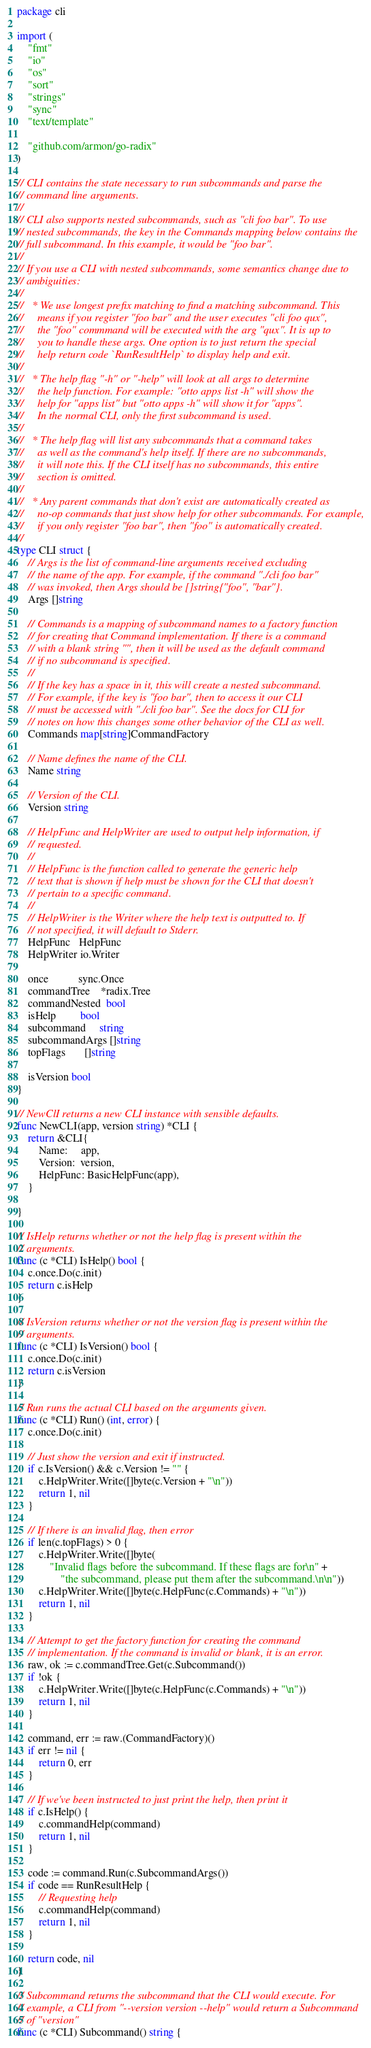<code> <loc_0><loc_0><loc_500><loc_500><_Go_>package cli

import (
	"fmt"
	"io"
	"os"
	"sort"
	"strings"
	"sync"
	"text/template"

	"github.com/armon/go-radix"
)

// CLI contains the state necessary to run subcommands and parse the
// command line arguments.
//
// CLI also supports nested subcommands, such as "cli foo bar". To use
// nested subcommands, the key in the Commands mapping below contains the
// full subcommand. In this example, it would be "foo bar".
//
// If you use a CLI with nested subcommands, some semantics change due to
// ambiguities:
//
//   * We use longest prefix matching to find a matching subcommand. This
//     means if you register "foo bar" and the user executes "cli foo qux",
//     the "foo" commmand will be executed with the arg "qux". It is up to
//     you to handle these args. One option is to just return the special
//     help return code `RunResultHelp` to display help and exit.
//
//   * The help flag "-h" or "-help" will look at all args to determine
//     the help function. For example: "otto apps list -h" will show the
//     help for "apps list" but "otto apps -h" will show it for "apps".
//     In the normal CLI, only the first subcommand is used.
//
//   * The help flag will list any subcommands that a command takes
//     as well as the command's help itself. If there are no subcommands,
//     it will note this. If the CLI itself has no subcommands, this entire
//     section is omitted.
//
//   * Any parent commands that don't exist are automatically created as
//     no-op commands that just show help for other subcommands. For example,
//     if you only register "foo bar", then "foo" is automatically created.
//
type CLI struct {
	// Args is the list of command-line arguments received excluding
	// the name of the app. For example, if the command "./cli foo bar"
	// was invoked, then Args should be []string{"foo", "bar"}.
	Args []string

	// Commands is a mapping of subcommand names to a factory function
	// for creating that Command implementation. If there is a command
	// with a blank string "", then it will be used as the default command
	// if no subcommand is specified.
	//
	// If the key has a space in it, this will create a nested subcommand.
	// For example, if the key is "foo bar", then to access it our CLI
	// must be accessed with "./cli foo bar". See the docs for CLI for
	// notes on how this changes some other behavior of the CLI as well.
	Commands map[string]CommandFactory

	// Name defines the name of the CLI.
	Name string

	// Version of the CLI.
	Version string

	// HelpFunc and HelpWriter are used to output help information, if
	// requested.
	//
	// HelpFunc is the function called to generate the generic help
	// text that is shown if help must be shown for the CLI that doesn't
	// pertain to a specific command.
	//
	// HelpWriter is the Writer where the help text is outputted to. If
	// not specified, it will default to Stderr.
	HelpFunc   HelpFunc
	HelpWriter io.Writer

	once           sync.Once
	commandTree    *radix.Tree
	commandNested  bool
	isHelp         bool
	subcommand     string
	subcommandArgs []string
	topFlags       []string

	isVersion bool
}

// NewClI returns a new CLI instance with sensible defaults.
func NewCLI(app, version string) *CLI {
	return &CLI{
		Name:     app,
		Version:  version,
		HelpFunc: BasicHelpFunc(app),
	}

}

// IsHelp returns whether or not the help flag is present within the
// arguments.
func (c *CLI) IsHelp() bool {
	c.once.Do(c.init)
	return c.isHelp
}

// IsVersion returns whether or not the version flag is present within the
// arguments.
func (c *CLI) IsVersion() bool {
	c.once.Do(c.init)
	return c.isVersion
}

// Run runs the actual CLI based on the arguments given.
func (c *CLI) Run() (int, error) {
	c.once.Do(c.init)

	// Just show the version and exit if instructed.
	if c.IsVersion() && c.Version != "" {
		c.HelpWriter.Write([]byte(c.Version + "\n"))
		return 1, nil
	}

	// If there is an invalid flag, then error
	if len(c.topFlags) > 0 {
		c.HelpWriter.Write([]byte(
			"Invalid flags before the subcommand. If these flags are for\n" +
				"the subcommand, please put them after the subcommand.\n\n"))
		c.HelpWriter.Write([]byte(c.HelpFunc(c.Commands) + "\n"))
		return 1, nil
	}

	// Attempt to get the factory function for creating the command
	// implementation. If the command is invalid or blank, it is an error.
	raw, ok := c.commandTree.Get(c.Subcommand())
	if !ok {
		c.HelpWriter.Write([]byte(c.HelpFunc(c.Commands) + "\n"))
		return 1, nil
	}

	command, err := raw.(CommandFactory)()
	if err != nil {
		return 0, err
	}

	// If we've been instructed to just print the help, then print it
	if c.IsHelp() {
		c.commandHelp(command)
		return 1, nil
	}

	code := command.Run(c.SubcommandArgs())
	if code == RunResultHelp {
		// Requesting help
		c.commandHelp(command)
		return 1, nil
	}

	return code, nil
}

// Subcommand returns the subcommand that the CLI would execute. For
// example, a CLI from "--version version --help" would return a Subcommand
// of "version"
func (c *CLI) Subcommand() string {</code> 